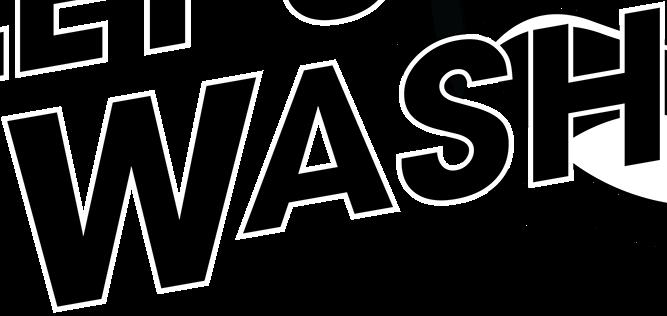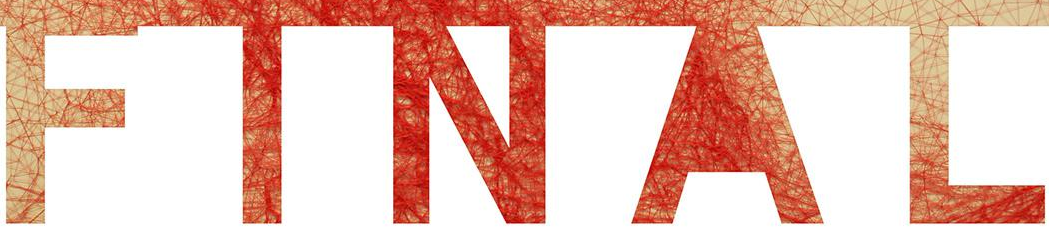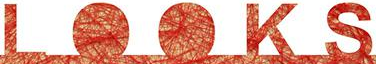Read the text content from these images in order, separated by a semicolon. WASH; FINAL; LOOKS 